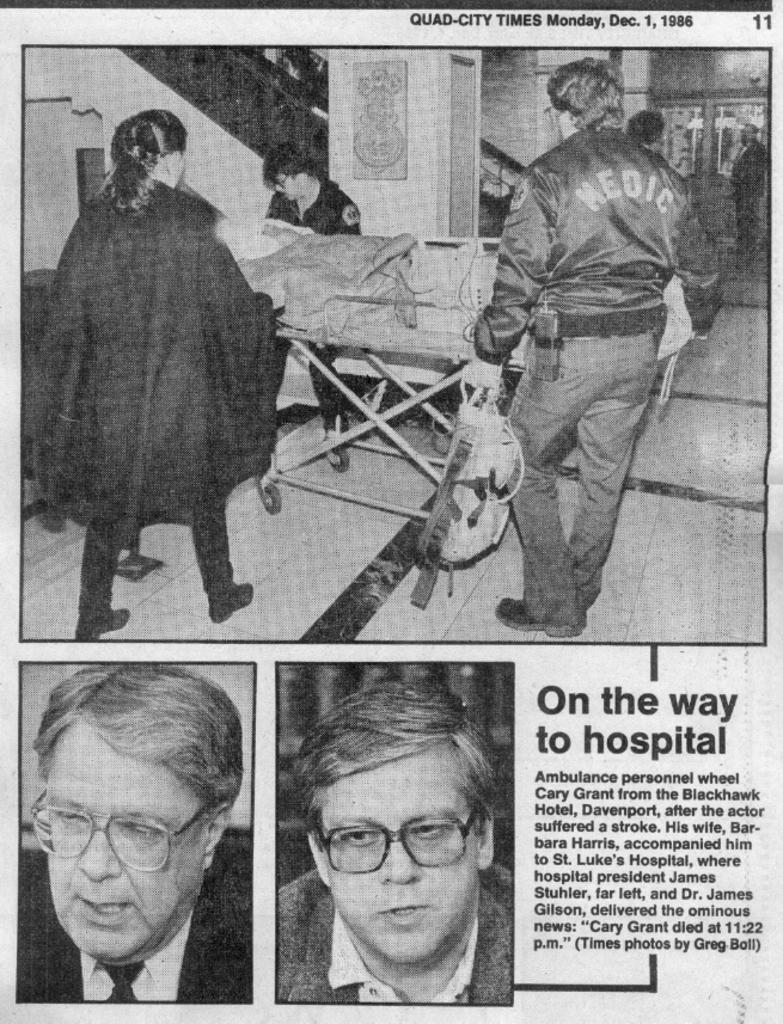<image>
Summarize the visual content of the image. Newspaper about being on the way to the hospital 